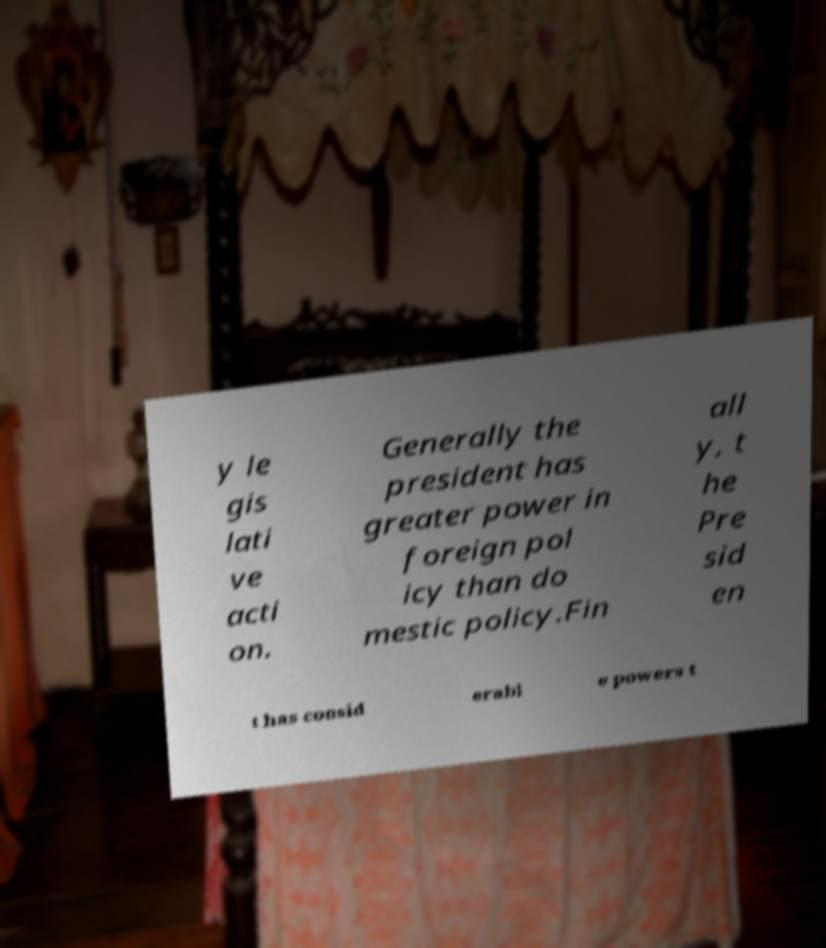Could you assist in decoding the text presented in this image and type it out clearly? y le gis lati ve acti on. Generally the president has greater power in foreign pol icy than do mestic policy.Fin all y, t he Pre sid en t has consid erabl e powers t 